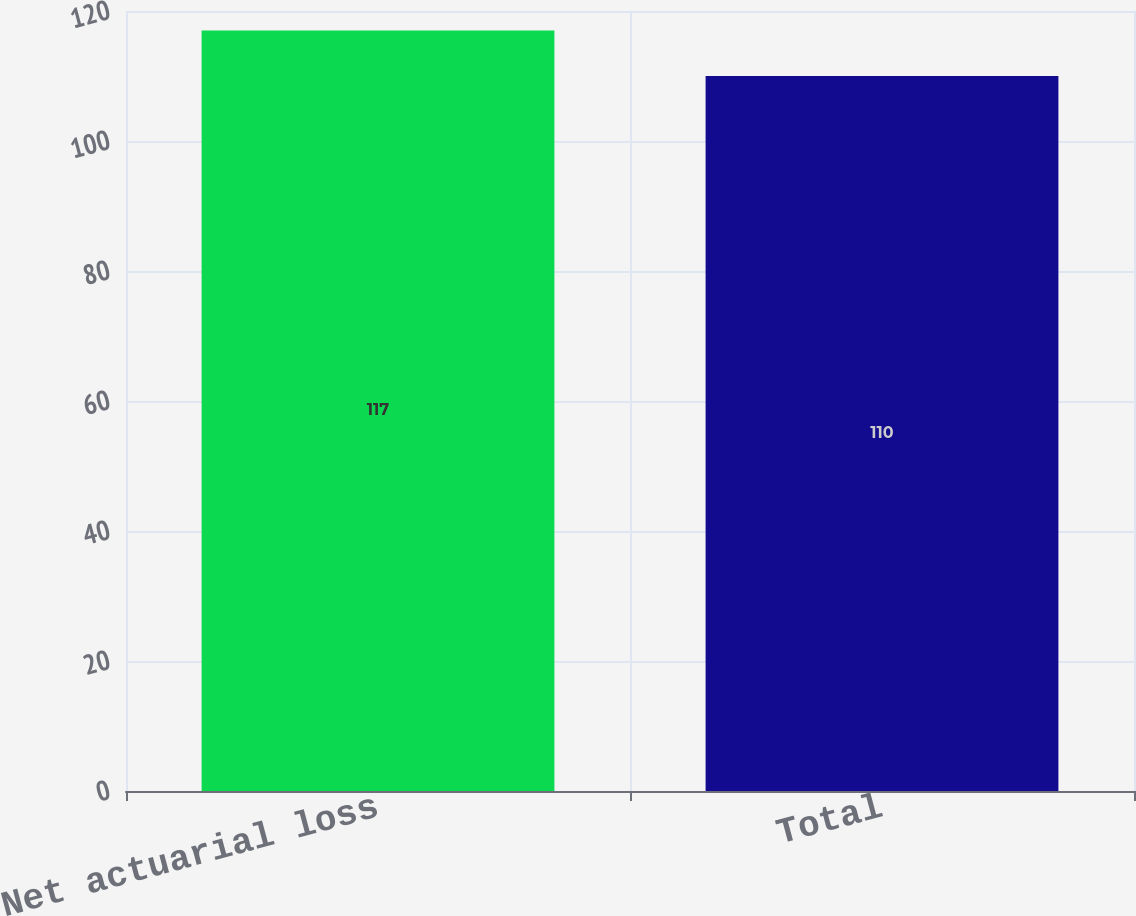<chart> <loc_0><loc_0><loc_500><loc_500><bar_chart><fcel>Net actuarial loss<fcel>Total<nl><fcel>117<fcel>110<nl></chart> 